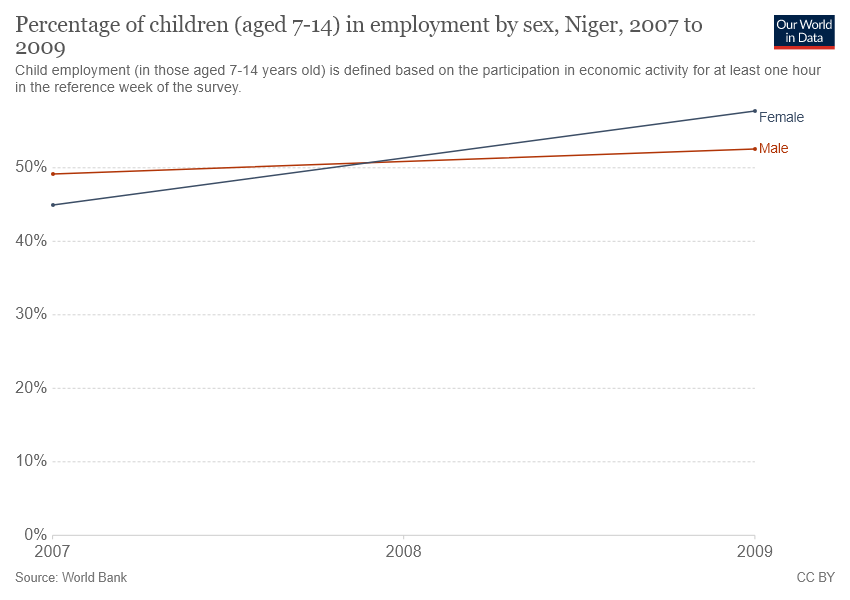Give some essential details in this illustration. At what point did the male and female lines in the graph cross each other? The highest percentage of women (age 7-14) in employment was recorded in 2009. 